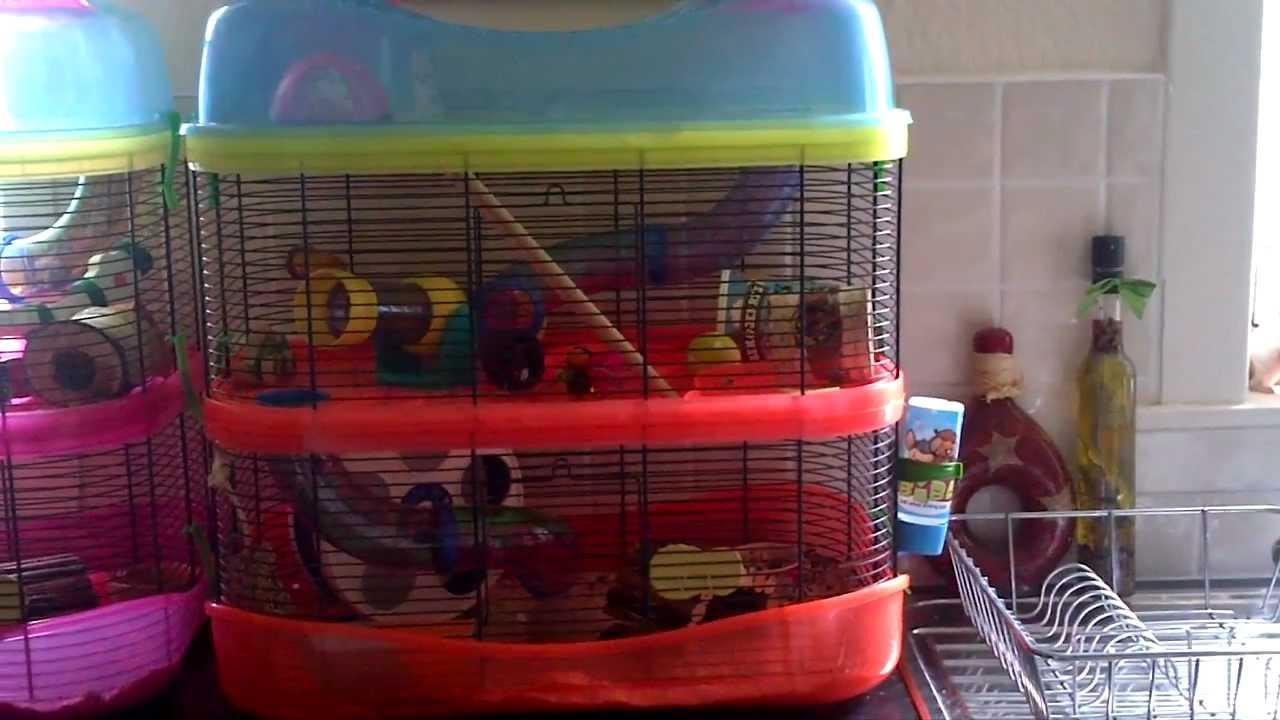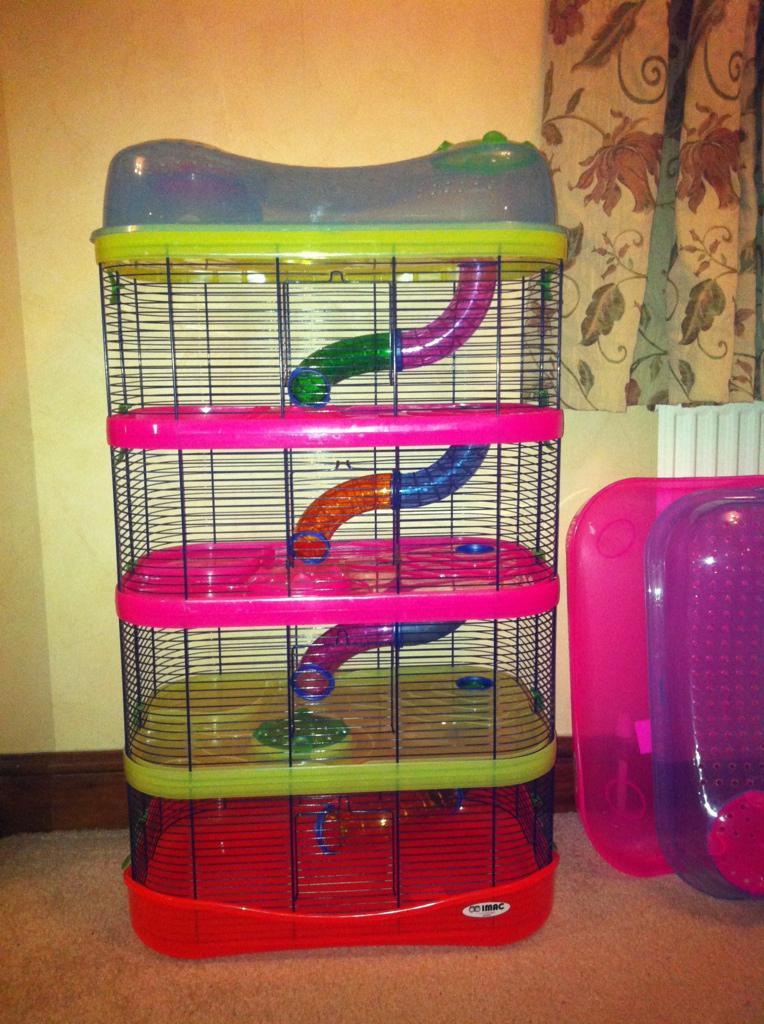The first image is the image on the left, the second image is the image on the right. Given the left and right images, does the statement "A small pet habitat features a white disk with purple border and yellow dot at the center." hold true? Answer yes or no. No. The first image is the image on the left, the second image is the image on the right. Assess this claim about the two images: "Both hamster cages have 2 stories.". Correct or not? Answer yes or no. No. 